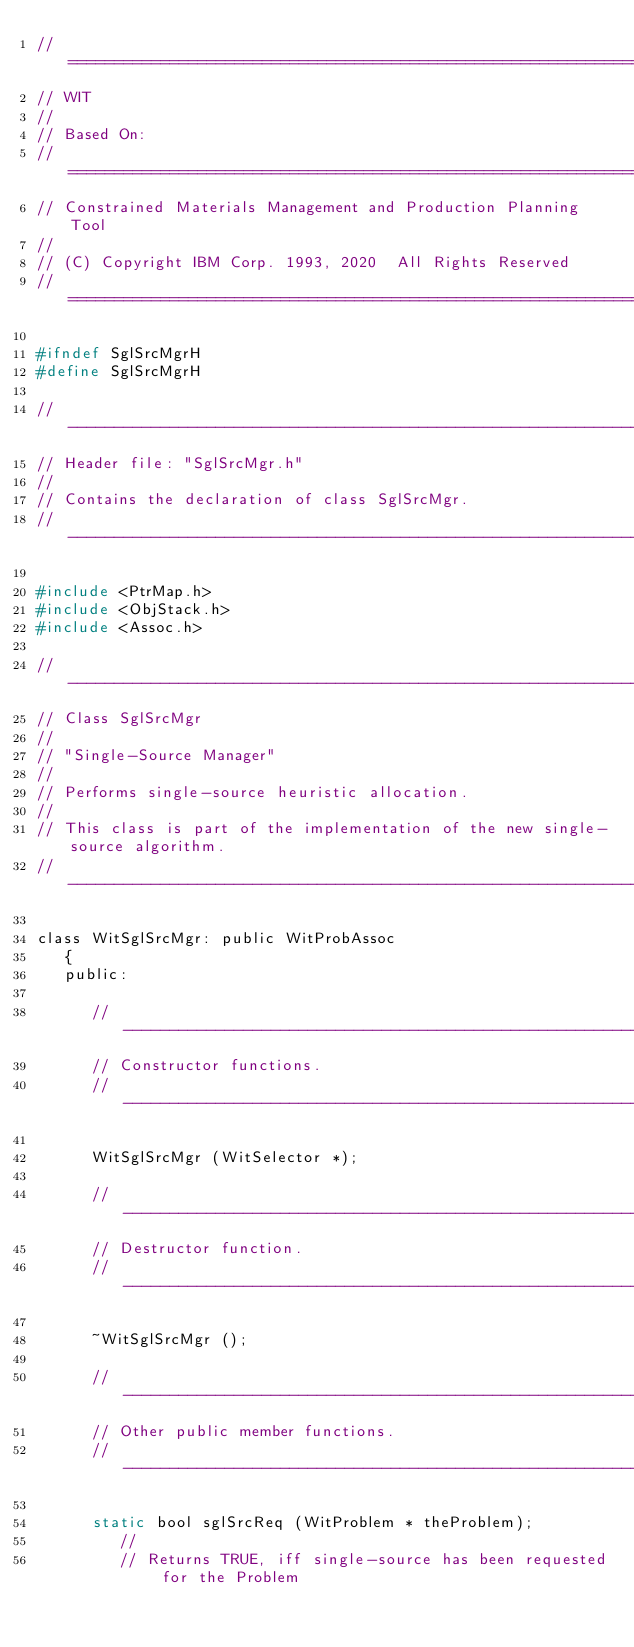Convert code to text. <code><loc_0><loc_0><loc_500><loc_500><_C_>//==============================================================================
// WIT
//
// Based On:
//==============================================================================
// Constrained Materials Management and Production Planning Tool
//
// (C) Copyright IBM Corp. 1993, 2020  All Rights Reserved
//==============================================================================

#ifndef SglSrcMgrH
#define SglSrcMgrH

//------------------------------------------------------------------------------
// Header file: "SglSrcMgr.h"
//
// Contains the declaration of class SglSrcMgr.
//------------------------------------------------------------------------------

#include <PtrMap.h>
#include <ObjStack.h>
#include <Assoc.h>

//------------------------------------------------------------------------------
// Class SglSrcMgr
//
// "Single-Source Manager"
//
// Performs single-source heuristic allocation.
//
// This class is part of the implementation of the new single-source algorithm.
//------------------------------------------------------------------------------

class WitSglSrcMgr: public WitProbAssoc
   {
   public:

      //------------------------------------------------------------------------
      // Constructor functions.
      //------------------------------------------------------------------------

      WitSglSrcMgr (WitSelector *);

      //------------------------------------------------------------------------
      // Destructor function.
      //------------------------------------------------------------------------

      ~WitSglSrcMgr ();

      //------------------------------------------------------------------------
      // Other public member functions.
      //------------------------------------------------------------------------

      static bool sglSrcReq (WitProblem * theProblem);
         //
         // Returns TRUE, iff single-source has been requested for the Problem
</code> 